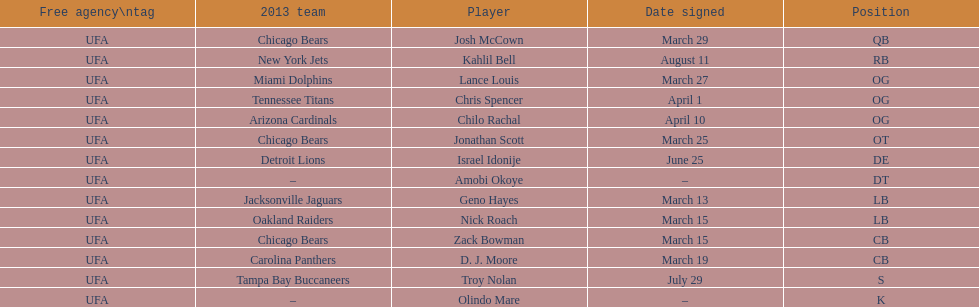Parse the full table. {'header': ['Free agency\\ntag', '2013 team', 'Player', 'Date signed', 'Position'], 'rows': [['UFA', 'Chicago Bears', 'Josh McCown', 'March 29', 'QB'], ['UFA', 'New York Jets', 'Kahlil Bell', 'August 11', 'RB'], ['UFA', 'Miami Dolphins', 'Lance Louis', 'March 27', 'OG'], ['UFA', 'Tennessee Titans', 'Chris Spencer', 'April 1', 'OG'], ['UFA', 'Arizona Cardinals', 'Chilo Rachal', 'April 10', 'OG'], ['UFA', 'Chicago Bears', 'Jonathan Scott', 'March 25', 'OT'], ['UFA', 'Detroit Lions', 'Israel Idonije', 'June 25', 'DE'], ['UFA', '–', 'Amobi Okoye', '–', 'DT'], ['UFA', 'Jacksonville Jaguars', 'Geno Hayes', 'March 13', 'LB'], ['UFA', 'Oakland Raiders', 'Nick Roach', 'March 15', 'LB'], ['UFA', 'Chicago Bears', 'Zack Bowman', 'March 15', 'CB'], ['UFA', 'Carolina Panthers', 'D. J. Moore', 'March 19', 'CB'], ['UFA', 'Tampa Bay Buccaneers', 'Troy Nolan', 'July 29', 'S'], ['UFA', '–', 'Olindo Mare', '–', 'K']]} His/her first name is the same name as a country. Israel Idonije. 